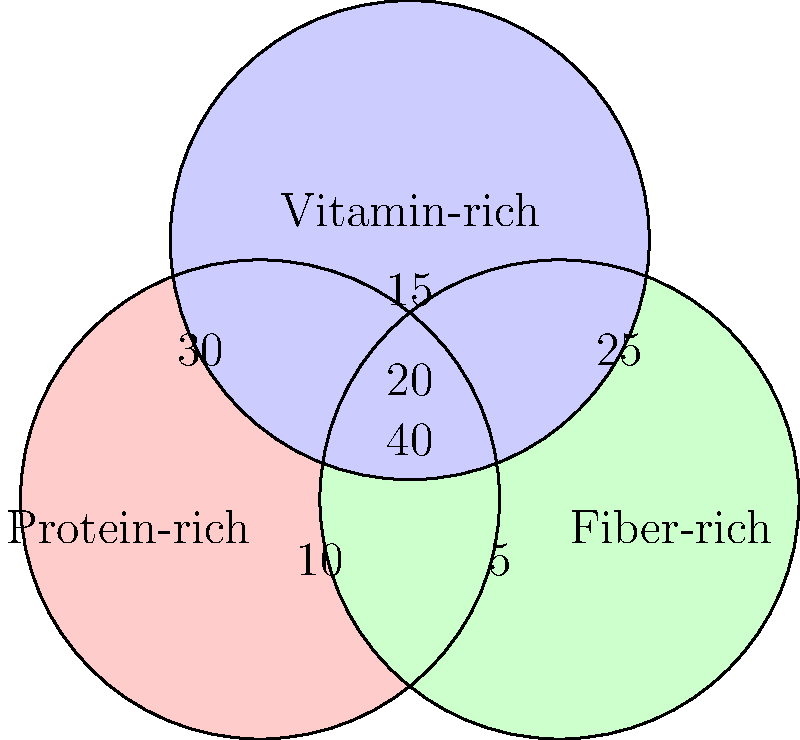Based on the Venn diagram representing dietary pattern groups, what percentage of the total population follows a diet that is both protein-rich and fiber-rich but not vitamin-rich? To solve this problem, we need to follow these steps:

1. Identify the region in the Venn diagram that represents diets that are both protein-rich and fiber-rich but not vitamin-rich.
2. This region is the intersection of the "Protein-rich" and "Fiber-rich" circles, excluding the overlap with the "Vitamin-rich" circle.
3. The number in this region is 5.
4. To calculate the percentage, we need to sum all the numbers in the diagram to get the total population:
   $$40 + 30 + 25 + 15 + 10 + 5 + 20 = 145$$
5. Calculate the percentage:
   $$\frac{5}{145} \times 100\% \approx 3.45\%$$

Therefore, approximately 3.45% of the total population follows a diet that is both protein-rich and fiber-rich but not vitamin-rich.
Answer: 3.45% 